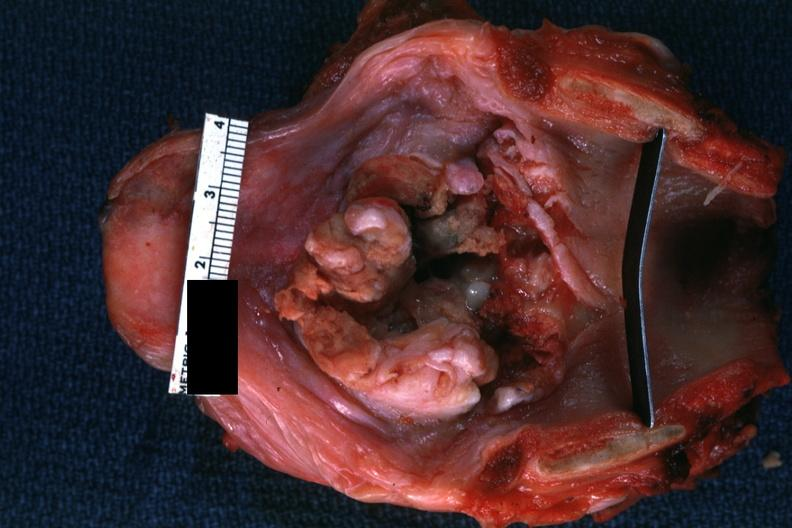s metastatic carcinoma lung present?
Answer the question using a single word or phrase. No 